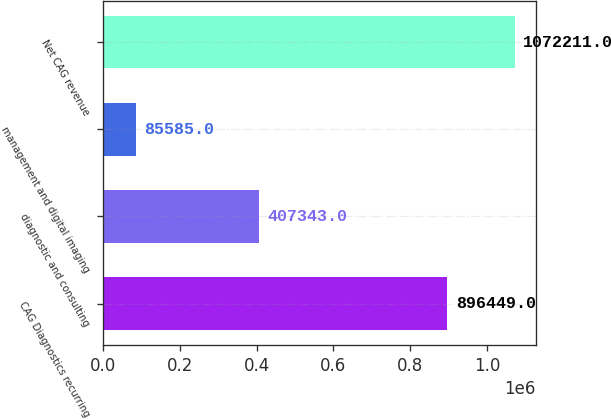Convert chart. <chart><loc_0><loc_0><loc_500><loc_500><bar_chart><fcel>CAG Diagnostics recurring<fcel>diagnostic and consulting<fcel>management and digital imaging<fcel>Net CAG revenue<nl><fcel>896449<fcel>407343<fcel>85585<fcel>1.07221e+06<nl></chart> 